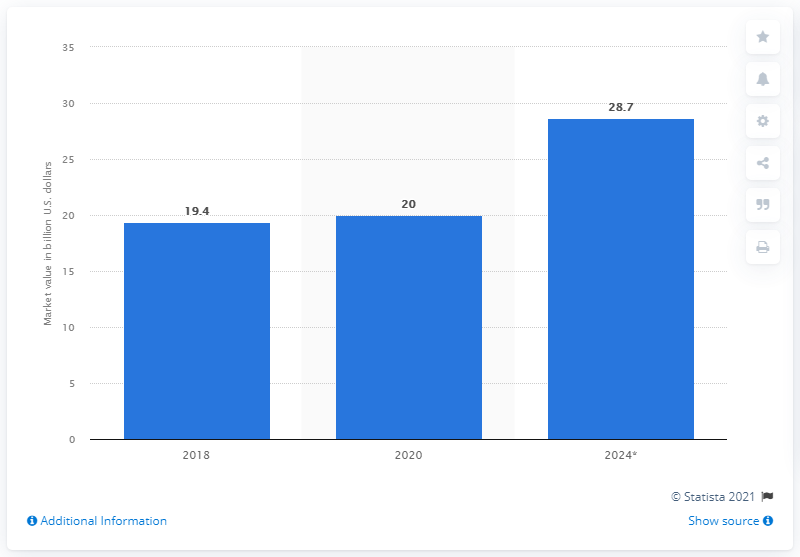Highlight a few significant elements in this photo. The projected global market value of organic dairy products is expected to increase by 2024, according to a recent study. This growth is expected to reach 28.7% over the next five years. In 2020, the global market value of organic dairy products was estimated to be $20 billion. 